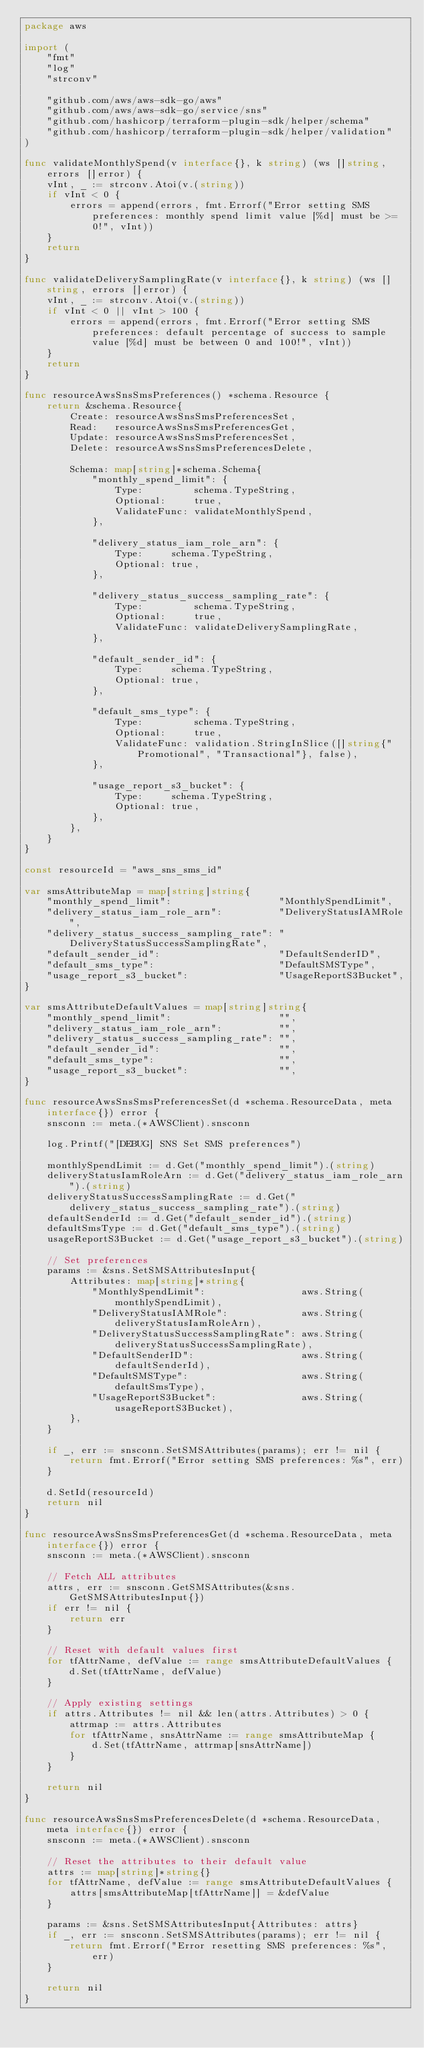Convert code to text. <code><loc_0><loc_0><loc_500><loc_500><_Go_>package aws

import (
	"fmt"
	"log"
	"strconv"

	"github.com/aws/aws-sdk-go/aws"
	"github.com/aws/aws-sdk-go/service/sns"
	"github.com/hashicorp/terraform-plugin-sdk/helper/schema"
	"github.com/hashicorp/terraform-plugin-sdk/helper/validation"
)

func validateMonthlySpend(v interface{}, k string) (ws []string, errors []error) {
	vInt, _ := strconv.Atoi(v.(string))
	if vInt < 0 {
		errors = append(errors, fmt.Errorf("Error setting SMS preferences: monthly spend limit value [%d] must be >= 0!", vInt))
	}
	return
}

func validateDeliverySamplingRate(v interface{}, k string) (ws []string, errors []error) {
	vInt, _ := strconv.Atoi(v.(string))
	if vInt < 0 || vInt > 100 {
		errors = append(errors, fmt.Errorf("Error setting SMS preferences: default percentage of success to sample value [%d] must be between 0 and 100!", vInt))
	}
	return
}

func resourceAwsSnsSmsPreferences() *schema.Resource {
	return &schema.Resource{
		Create: resourceAwsSnsSmsPreferencesSet,
		Read:   resourceAwsSnsSmsPreferencesGet,
		Update: resourceAwsSnsSmsPreferencesSet,
		Delete: resourceAwsSnsSmsPreferencesDelete,

		Schema: map[string]*schema.Schema{
			"monthly_spend_limit": {
				Type:         schema.TypeString,
				Optional:     true,
				ValidateFunc: validateMonthlySpend,
			},

			"delivery_status_iam_role_arn": {
				Type:     schema.TypeString,
				Optional: true,
			},

			"delivery_status_success_sampling_rate": {
				Type:         schema.TypeString,
				Optional:     true,
				ValidateFunc: validateDeliverySamplingRate,
			},

			"default_sender_id": {
				Type:     schema.TypeString,
				Optional: true,
			},

			"default_sms_type": {
				Type:         schema.TypeString,
				Optional:     true,
				ValidateFunc: validation.StringInSlice([]string{"Promotional", "Transactional"}, false),
			},

			"usage_report_s3_bucket": {
				Type:     schema.TypeString,
				Optional: true,
			},
		},
	}
}

const resourceId = "aws_sns_sms_id"

var smsAttributeMap = map[string]string{
	"monthly_spend_limit":                   "MonthlySpendLimit",
	"delivery_status_iam_role_arn":          "DeliveryStatusIAMRole",
	"delivery_status_success_sampling_rate": "DeliveryStatusSuccessSamplingRate",
	"default_sender_id":                     "DefaultSenderID",
	"default_sms_type":                      "DefaultSMSType",
	"usage_report_s3_bucket":                "UsageReportS3Bucket",
}

var smsAttributeDefaultValues = map[string]string{
	"monthly_spend_limit":                   "",
	"delivery_status_iam_role_arn":          "",
	"delivery_status_success_sampling_rate": "",
	"default_sender_id":                     "",
	"default_sms_type":                      "",
	"usage_report_s3_bucket":                "",
}

func resourceAwsSnsSmsPreferencesSet(d *schema.ResourceData, meta interface{}) error {
	snsconn := meta.(*AWSClient).snsconn

	log.Printf("[DEBUG] SNS Set SMS preferences")

	monthlySpendLimit := d.Get("monthly_spend_limit").(string)
	deliveryStatusIamRoleArn := d.Get("delivery_status_iam_role_arn").(string)
	deliveryStatusSuccessSamplingRate := d.Get("delivery_status_success_sampling_rate").(string)
	defaultSenderId := d.Get("default_sender_id").(string)
	defaultSmsType := d.Get("default_sms_type").(string)
	usageReportS3Bucket := d.Get("usage_report_s3_bucket").(string)

	// Set preferences
	params := &sns.SetSMSAttributesInput{
		Attributes: map[string]*string{
			"MonthlySpendLimit":                 aws.String(monthlySpendLimit),
			"DeliveryStatusIAMRole":             aws.String(deliveryStatusIamRoleArn),
			"DeliveryStatusSuccessSamplingRate": aws.String(deliveryStatusSuccessSamplingRate),
			"DefaultSenderID":                   aws.String(defaultSenderId),
			"DefaultSMSType":                    aws.String(defaultSmsType),
			"UsageReportS3Bucket":               aws.String(usageReportS3Bucket),
		},
	}

	if _, err := snsconn.SetSMSAttributes(params); err != nil {
		return fmt.Errorf("Error setting SMS preferences: %s", err)
	}

	d.SetId(resourceId)
	return nil
}

func resourceAwsSnsSmsPreferencesGet(d *schema.ResourceData, meta interface{}) error {
	snsconn := meta.(*AWSClient).snsconn

	// Fetch ALL attributes
	attrs, err := snsconn.GetSMSAttributes(&sns.GetSMSAttributesInput{})
	if err != nil {
		return err
	}

	// Reset with default values first
	for tfAttrName, defValue := range smsAttributeDefaultValues {
		d.Set(tfAttrName, defValue)
	}

	// Apply existing settings
	if attrs.Attributes != nil && len(attrs.Attributes) > 0 {
		attrmap := attrs.Attributes
		for tfAttrName, snsAttrName := range smsAttributeMap {
			d.Set(tfAttrName, attrmap[snsAttrName])
		}
	}

	return nil
}

func resourceAwsSnsSmsPreferencesDelete(d *schema.ResourceData, meta interface{}) error {
	snsconn := meta.(*AWSClient).snsconn

	// Reset the attributes to their default value
	attrs := map[string]*string{}
	for tfAttrName, defValue := range smsAttributeDefaultValues {
		attrs[smsAttributeMap[tfAttrName]] = &defValue
	}

	params := &sns.SetSMSAttributesInput{Attributes: attrs}
	if _, err := snsconn.SetSMSAttributes(params); err != nil {
		return fmt.Errorf("Error resetting SMS preferences: %s", err)
	}

	return nil
}
</code> 